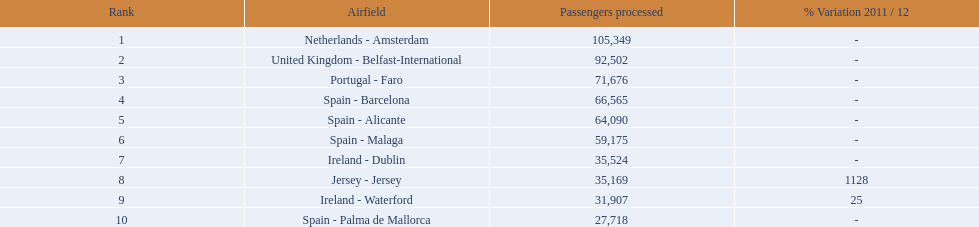Which airports are in europe? Netherlands - Amsterdam, United Kingdom - Belfast-International, Portugal - Faro, Spain - Barcelona, Spain - Alicante, Spain - Malaga, Ireland - Dublin, Ireland - Waterford, Spain - Palma de Mallorca. Which one is from portugal? Portugal - Faro. 